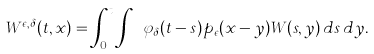Convert formula to latex. <formula><loc_0><loc_0><loc_500><loc_500>W ^ { \epsilon , \delta } ( t , x ) = \int _ { 0 } ^ { t } \int _ { \mathbb { R } ^ { d } } \varphi _ { \delta } ( t - s ) p _ { \epsilon } ( x - y ) W ( s , y ) \, d s \, d y .</formula> 